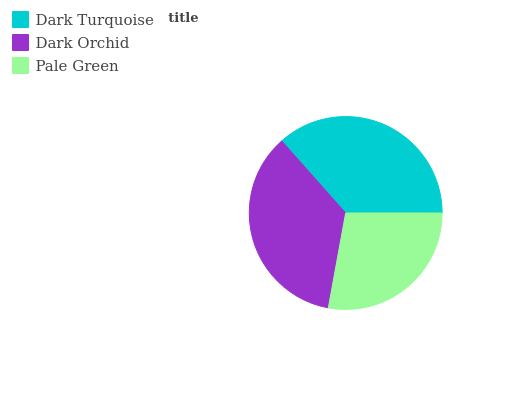Is Pale Green the minimum?
Answer yes or no. Yes. Is Dark Turquoise the maximum?
Answer yes or no. Yes. Is Dark Orchid the minimum?
Answer yes or no. No. Is Dark Orchid the maximum?
Answer yes or no. No. Is Dark Turquoise greater than Dark Orchid?
Answer yes or no. Yes. Is Dark Orchid less than Dark Turquoise?
Answer yes or no. Yes. Is Dark Orchid greater than Dark Turquoise?
Answer yes or no. No. Is Dark Turquoise less than Dark Orchid?
Answer yes or no. No. Is Dark Orchid the high median?
Answer yes or no. Yes. Is Dark Orchid the low median?
Answer yes or no. Yes. Is Pale Green the high median?
Answer yes or no. No. Is Dark Turquoise the low median?
Answer yes or no. No. 